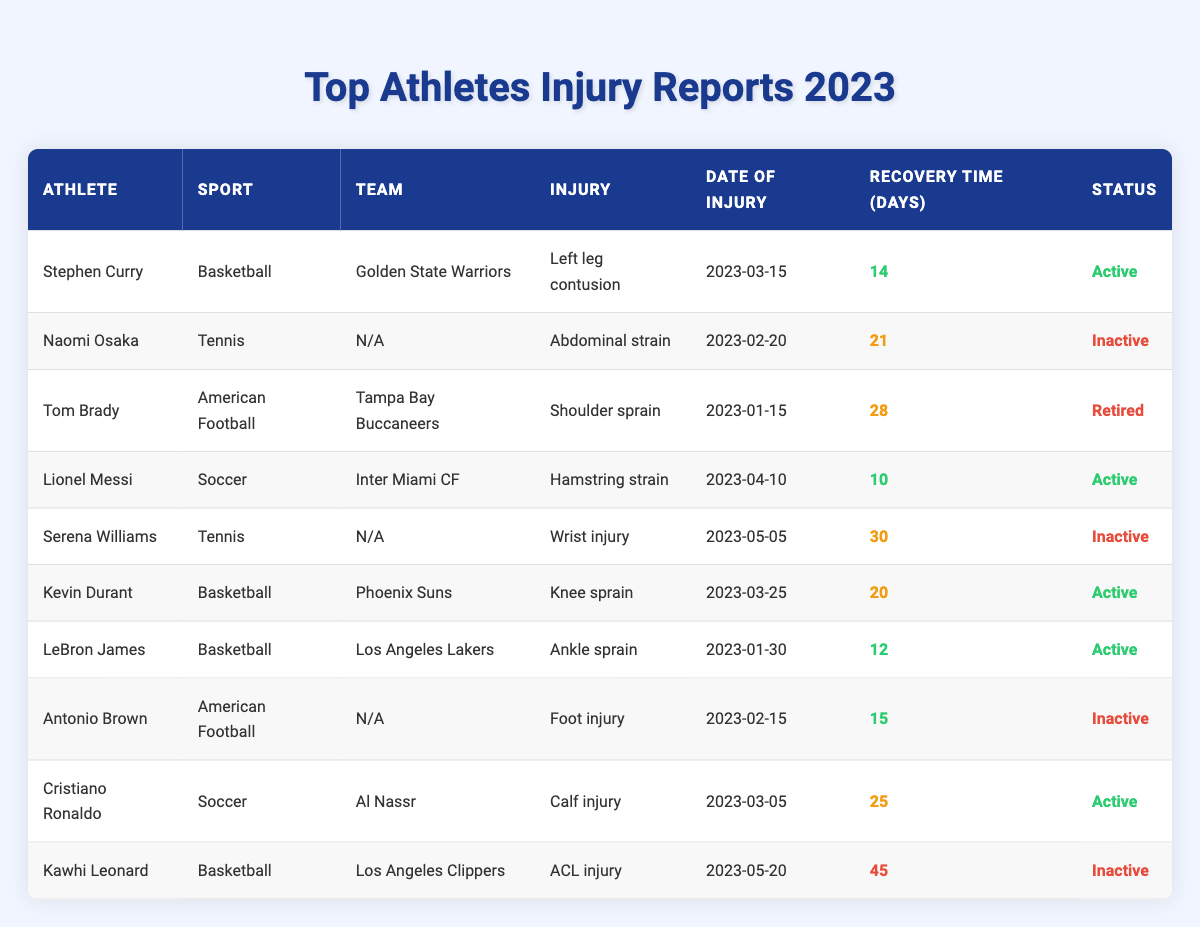What injury did Stephen Curry sustain? The table lists Stephen Curry's injury as a "Left leg contusion."
Answer: Left leg contusion How long is Kevin Durant's recovery time? According to the table, Kevin Durant's recovery time is noted as 20 days.
Answer: 20 days Is Tom Brady still active as an athlete? The table indicates that Tom Brady's status is "Retired," which means he is not currently an active athlete.
Answer: No Who has the longest recovery time among the athletes listed? By examining the recovery times, Kawhi Leonard has the longest recovery time at 45 days.
Answer: Kawhi Leonard Which athlete returned to play the quickest after their injury? The table shows that Lionel Messi had the shortest recovery time of 10 days, indicating he returned quickest.
Answer: Lionel Messi What is the average recovery time of inactive athletes from this table? The inactive athletes are Naomi Osaka (21 days), Serena Williams (30 days), Antonio Brown (15 days), and Kawhi Leonard (45 days). The average is calculated as (21 + 30 + 15 + 45) / 4 = 27.75 days.
Answer: 27.75 days How many athletes are currently active following their injuries? The table shows that there are five athletes marked as "Active": Stephen Curry, Lionel Messi, Kevin Durant, LeBron James, and Cristiano Ronaldo.
Answer: 5 What percentage of the athletes listed are inactive? There are 10 athletes total, with 4 marked as inactive (Naomi Osaka, Serena Williams, Antonio Brown, and Kawhi Leonard). The percentage is (4/10) * 100 = 40%.
Answer: 40% Is there any athlete with an injury that resulted in a recovery time shorter than 15 days? By reviewing the table, the only athlete with a recovery time shorter than 15 days is LeBron James with 12 days.
Answer: Yes What injuries did athletes from the sport of Tennis sustain? The table highlights two tennis athletes: Naomi Osaka (Abdominal strain) and Serena Williams (Wrist injury).
Answer: Abdominal strain and Wrist injury 